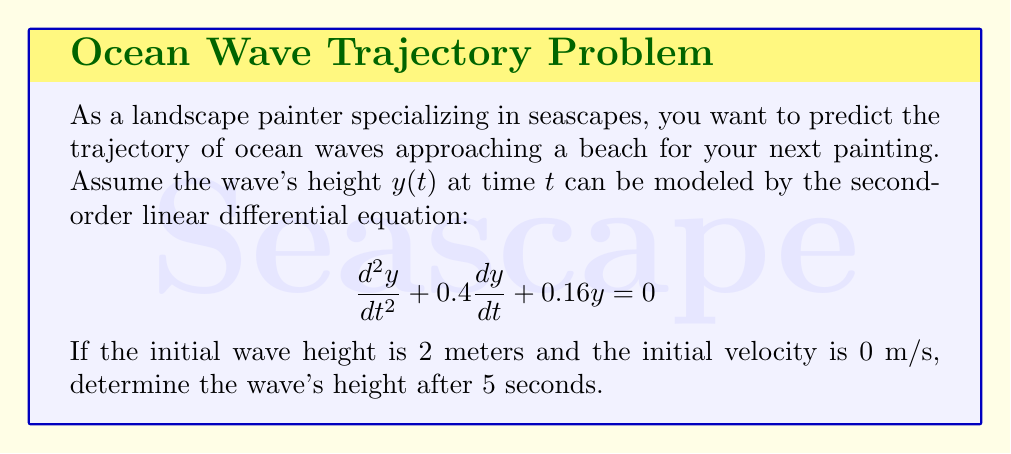Help me with this question. To solve this problem, we need to follow these steps:

1) The given differential equation is in the form:
   $$\frac{d^2y}{dt^2} + 2\zeta\omega_n\frac{dy}{dt} + \omega_n^2y = 0$$
   where $\zeta$ is the damping ratio and $\omega_n$ is the natural frequency.

2) Comparing our equation to this form, we see that:
   $2\zeta\omega_n = 0.4$ and $\omega_n^2 = 0.16$

3) From $\omega_n^2 = 0.16$, we get $\omega_n = 0.4$ rad/s

4) Substituting this into $2\zeta\omega_n = 0.4$, we get:
   $2\zeta(0.4) = 0.4$
   $\zeta = 0.5$

5) Since $\zeta = 0.5$, this is a critically damped system. The general solution for a critically damped system is:
   $$y(t) = e^{-\zeta\omega_nt}(C_1 + C_2t)$$

6) Substituting our values:
   $$y(t) = e^{-0.2t}(C_1 + C_2t)$$

7) We need to find $C_1$ and $C_2$ using the initial conditions:
   At $t = 0$, $y(0) = 2$ and $y'(0) = 0$

8) From $y(0) = 2$:
   $2 = C_1$

9) Taking the derivative of $y(t)$:
   $$y'(t) = -0.2e^{-0.2t}(C_1 + C_2t) + e^{-0.2t}C_2$$

10) From $y'(0) = 0$:
    $0 = -0.2C_1 + C_2$
    $C_2 = 0.2C_1 = 0.4$

11) Therefore, the complete solution is:
    $$y(t) = e^{-0.2t}(2 + 0.4t)$$

12) To find the height after 5 seconds, we substitute $t = 5$:
    $$y(5) = e^{-0.2(5)}(2 + 0.4(5))$$
    $$y(5) = e^{-1}(2 + 2) = 4e^{-1}$$

13) Calculating this value:
    $$y(5) = 4 * 0.3679 = 1.4716$$
Answer: The wave's height after 5 seconds is approximately 1.47 meters. 